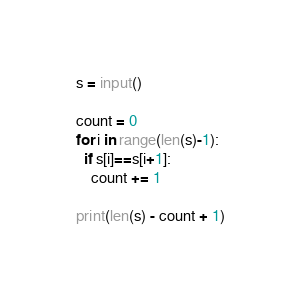Convert code to text. <code><loc_0><loc_0><loc_500><loc_500><_Python_>s = input()

count = 0
for i in range(len(s)-1):
  if s[i]==s[i+1]:
    count += 1

print(len(s) - count + 1)</code> 